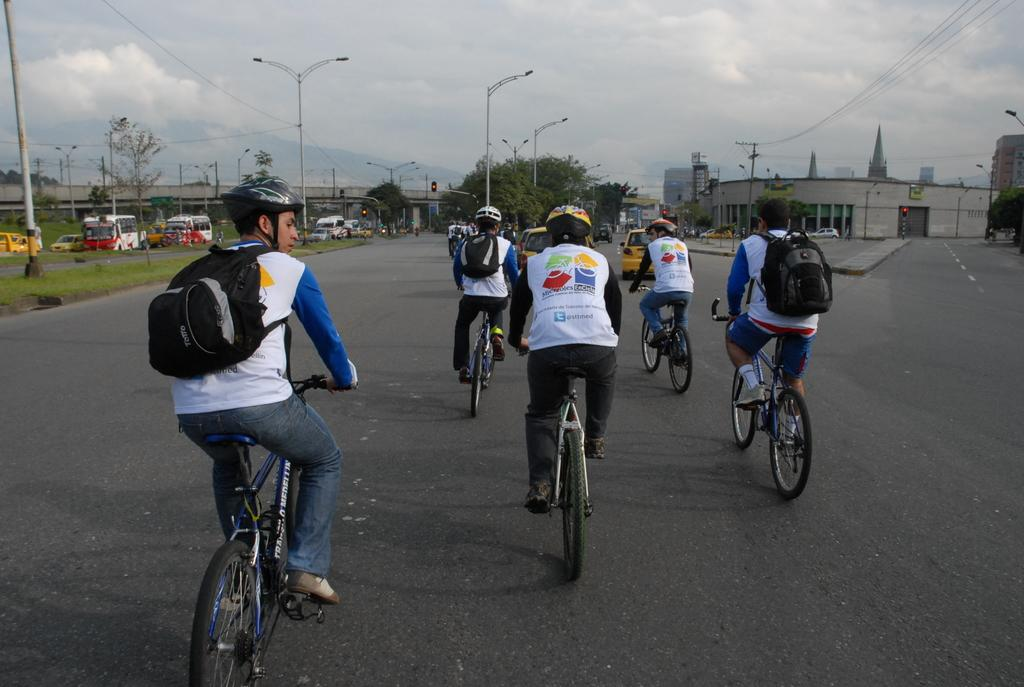What are the people in the image doing? The people in the image are riding bicycles. Where are the bicycles located? The bicycles are on a road. What can be seen in the background of the image? There are vehicles, poles, trees, and buildings in the background of the image. Where is the shelf located in the image? There is no shelf present in the image. What type of afterthought is being expressed by the people riding bicycles in the image? There is no indication of an afterthought being expressed by the people in the image; they are simply riding bicycles. 